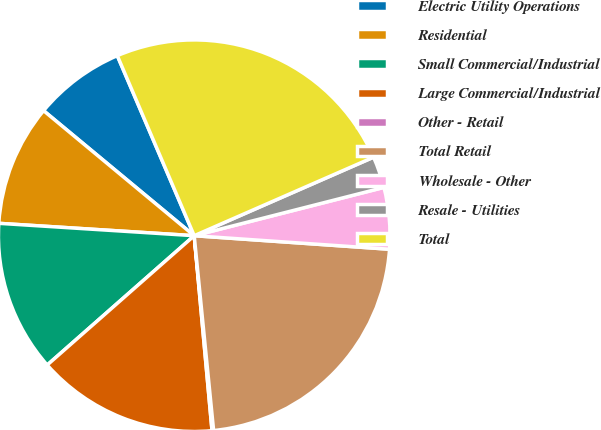<chart> <loc_0><loc_0><loc_500><loc_500><pie_chart><fcel>Electric Utility Operations<fcel>Residential<fcel>Small Commercial/Industrial<fcel>Large Commercial/Industrial<fcel>Other - Retail<fcel>Total Retail<fcel>Wholesale - Other<fcel>Resale - Utilities<fcel>Total<nl><fcel>7.55%<fcel>10.02%<fcel>12.49%<fcel>14.97%<fcel>0.13%<fcel>22.32%<fcel>5.07%<fcel>2.6%<fcel>24.86%<nl></chart> 